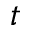Convert formula to latex. <formula><loc_0><loc_0><loc_500><loc_500>t</formula> 